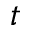Convert formula to latex. <formula><loc_0><loc_0><loc_500><loc_500>t</formula> 